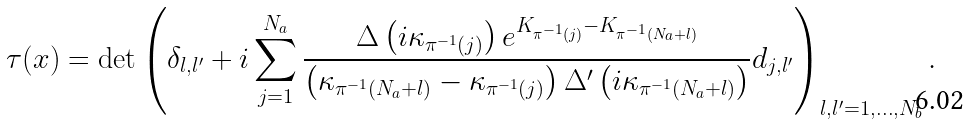Convert formula to latex. <formula><loc_0><loc_0><loc_500><loc_500>\tau ( x ) = \det \left ( \delta _ { l , l ^ { \prime } } + i \sum _ { j = 1 } ^ { N _ { a } } \frac { \Delta \left ( i \kappa _ { \pi ^ { - 1 } ( j ) } \right ) e ^ { K _ { \pi ^ { - 1 } ( j ) } - K _ { \pi ^ { - 1 } ( N _ { a } + l ) } } } { \left ( \kappa _ { \pi ^ { - 1 } ( N _ { a } + l ) } - \kappa _ { \pi ^ { - 1 } ( j ) } \right ) \Delta ^ { \prime } \left ( i \kappa _ { \pi ^ { - 1 } ( N _ { a } + l ) } \right ) } d _ { j , l ^ { \prime } } \right ) _ { l , l ^ { \prime } = 1 , \dots , N _ { b } } .</formula> 